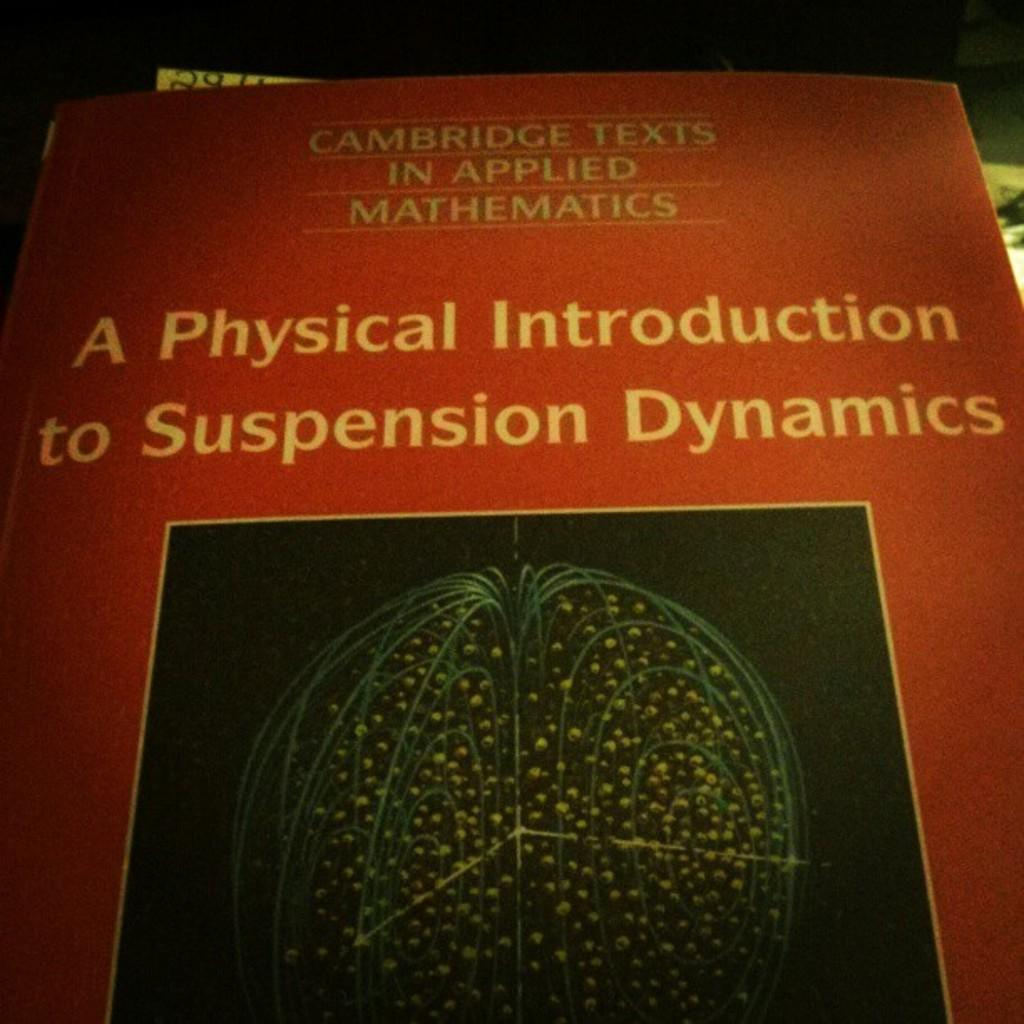<image>
Describe the image concisely. A red book from Cambridge about applied mathematics. 